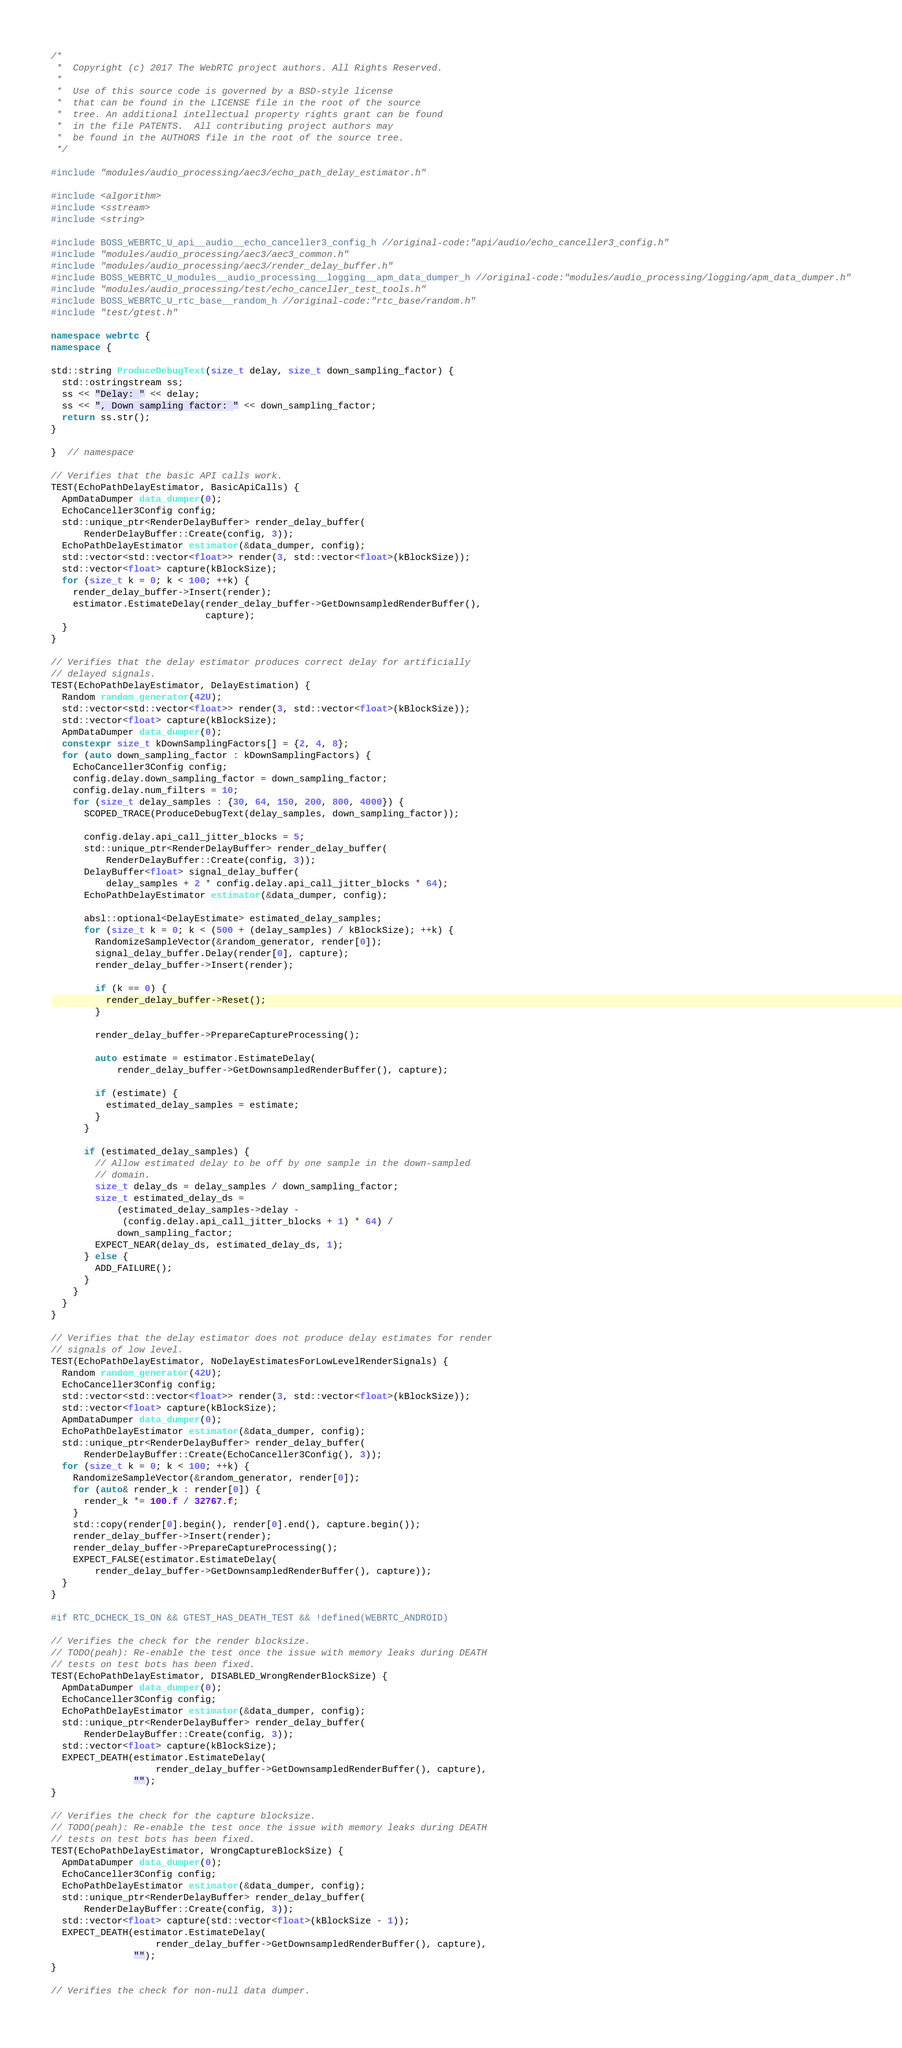Convert code to text. <code><loc_0><loc_0><loc_500><loc_500><_C++_>/*
 *  Copyright (c) 2017 The WebRTC project authors. All Rights Reserved.
 *
 *  Use of this source code is governed by a BSD-style license
 *  that can be found in the LICENSE file in the root of the source
 *  tree. An additional intellectual property rights grant can be found
 *  in the file PATENTS.  All contributing project authors may
 *  be found in the AUTHORS file in the root of the source tree.
 */

#include "modules/audio_processing/aec3/echo_path_delay_estimator.h"

#include <algorithm>
#include <sstream>
#include <string>

#include BOSS_WEBRTC_U_api__audio__echo_canceller3_config_h //original-code:"api/audio/echo_canceller3_config.h"
#include "modules/audio_processing/aec3/aec3_common.h"
#include "modules/audio_processing/aec3/render_delay_buffer.h"
#include BOSS_WEBRTC_U_modules__audio_processing__logging__apm_data_dumper_h //original-code:"modules/audio_processing/logging/apm_data_dumper.h"
#include "modules/audio_processing/test/echo_canceller_test_tools.h"
#include BOSS_WEBRTC_U_rtc_base__random_h //original-code:"rtc_base/random.h"
#include "test/gtest.h"

namespace webrtc {
namespace {

std::string ProduceDebugText(size_t delay, size_t down_sampling_factor) {
  std::ostringstream ss;
  ss << "Delay: " << delay;
  ss << ", Down sampling factor: " << down_sampling_factor;
  return ss.str();
}

}  // namespace

// Verifies that the basic API calls work.
TEST(EchoPathDelayEstimator, BasicApiCalls) {
  ApmDataDumper data_dumper(0);
  EchoCanceller3Config config;
  std::unique_ptr<RenderDelayBuffer> render_delay_buffer(
      RenderDelayBuffer::Create(config, 3));
  EchoPathDelayEstimator estimator(&data_dumper, config);
  std::vector<std::vector<float>> render(3, std::vector<float>(kBlockSize));
  std::vector<float> capture(kBlockSize);
  for (size_t k = 0; k < 100; ++k) {
    render_delay_buffer->Insert(render);
    estimator.EstimateDelay(render_delay_buffer->GetDownsampledRenderBuffer(),
                            capture);
  }
}

// Verifies that the delay estimator produces correct delay for artificially
// delayed signals.
TEST(EchoPathDelayEstimator, DelayEstimation) {
  Random random_generator(42U);
  std::vector<std::vector<float>> render(3, std::vector<float>(kBlockSize));
  std::vector<float> capture(kBlockSize);
  ApmDataDumper data_dumper(0);
  constexpr size_t kDownSamplingFactors[] = {2, 4, 8};
  for (auto down_sampling_factor : kDownSamplingFactors) {
    EchoCanceller3Config config;
    config.delay.down_sampling_factor = down_sampling_factor;
    config.delay.num_filters = 10;
    for (size_t delay_samples : {30, 64, 150, 200, 800, 4000}) {
      SCOPED_TRACE(ProduceDebugText(delay_samples, down_sampling_factor));

      config.delay.api_call_jitter_blocks = 5;
      std::unique_ptr<RenderDelayBuffer> render_delay_buffer(
          RenderDelayBuffer::Create(config, 3));
      DelayBuffer<float> signal_delay_buffer(
          delay_samples + 2 * config.delay.api_call_jitter_blocks * 64);
      EchoPathDelayEstimator estimator(&data_dumper, config);

      absl::optional<DelayEstimate> estimated_delay_samples;
      for (size_t k = 0; k < (500 + (delay_samples) / kBlockSize); ++k) {
        RandomizeSampleVector(&random_generator, render[0]);
        signal_delay_buffer.Delay(render[0], capture);
        render_delay_buffer->Insert(render);

        if (k == 0) {
          render_delay_buffer->Reset();
        }

        render_delay_buffer->PrepareCaptureProcessing();

        auto estimate = estimator.EstimateDelay(
            render_delay_buffer->GetDownsampledRenderBuffer(), capture);

        if (estimate) {
          estimated_delay_samples = estimate;
        }
      }

      if (estimated_delay_samples) {
        // Allow estimated delay to be off by one sample in the down-sampled
        // domain.
        size_t delay_ds = delay_samples / down_sampling_factor;
        size_t estimated_delay_ds =
            (estimated_delay_samples->delay -
             (config.delay.api_call_jitter_blocks + 1) * 64) /
            down_sampling_factor;
        EXPECT_NEAR(delay_ds, estimated_delay_ds, 1);
      } else {
        ADD_FAILURE();
      }
    }
  }
}

// Verifies that the delay estimator does not produce delay estimates for render
// signals of low level.
TEST(EchoPathDelayEstimator, NoDelayEstimatesForLowLevelRenderSignals) {
  Random random_generator(42U);
  EchoCanceller3Config config;
  std::vector<std::vector<float>> render(3, std::vector<float>(kBlockSize));
  std::vector<float> capture(kBlockSize);
  ApmDataDumper data_dumper(0);
  EchoPathDelayEstimator estimator(&data_dumper, config);
  std::unique_ptr<RenderDelayBuffer> render_delay_buffer(
      RenderDelayBuffer::Create(EchoCanceller3Config(), 3));
  for (size_t k = 0; k < 100; ++k) {
    RandomizeSampleVector(&random_generator, render[0]);
    for (auto& render_k : render[0]) {
      render_k *= 100.f / 32767.f;
    }
    std::copy(render[0].begin(), render[0].end(), capture.begin());
    render_delay_buffer->Insert(render);
    render_delay_buffer->PrepareCaptureProcessing();
    EXPECT_FALSE(estimator.EstimateDelay(
        render_delay_buffer->GetDownsampledRenderBuffer(), capture));
  }
}

#if RTC_DCHECK_IS_ON && GTEST_HAS_DEATH_TEST && !defined(WEBRTC_ANDROID)

// Verifies the check for the render blocksize.
// TODO(peah): Re-enable the test once the issue with memory leaks during DEATH
// tests on test bots has been fixed.
TEST(EchoPathDelayEstimator, DISABLED_WrongRenderBlockSize) {
  ApmDataDumper data_dumper(0);
  EchoCanceller3Config config;
  EchoPathDelayEstimator estimator(&data_dumper, config);
  std::unique_ptr<RenderDelayBuffer> render_delay_buffer(
      RenderDelayBuffer::Create(config, 3));
  std::vector<float> capture(kBlockSize);
  EXPECT_DEATH(estimator.EstimateDelay(
                   render_delay_buffer->GetDownsampledRenderBuffer(), capture),
               "");
}

// Verifies the check for the capture blocksize.
// TODO(peah): Re-enable the test once the issue with memory leaks during DEATH
// tests on test bots has been fixed.
TEST(EchoPathDelayEstimator, WrongCaptureBlockSize) {
  ApmDataDumper data_dumper(0);
  EchoCanceller3Config config;
  EchoPathDelayEstimator estimator(&data_dumper, config);
  std::unique_ptr<RenderDelayBuffer> render_delay_buffer(
      RenderDelayBuffer::Create(config, 3));
  std::vector<float> capture(std::vector<float>(kBlockSize - 1));
  EXPECT_DEATH(estimator.EstimateDelay(
                   render_delay_buffer->GetDownsampledRenderBuffer(), capture),
               "");
}

// Verifies the check for non-null data dumper.</code> 